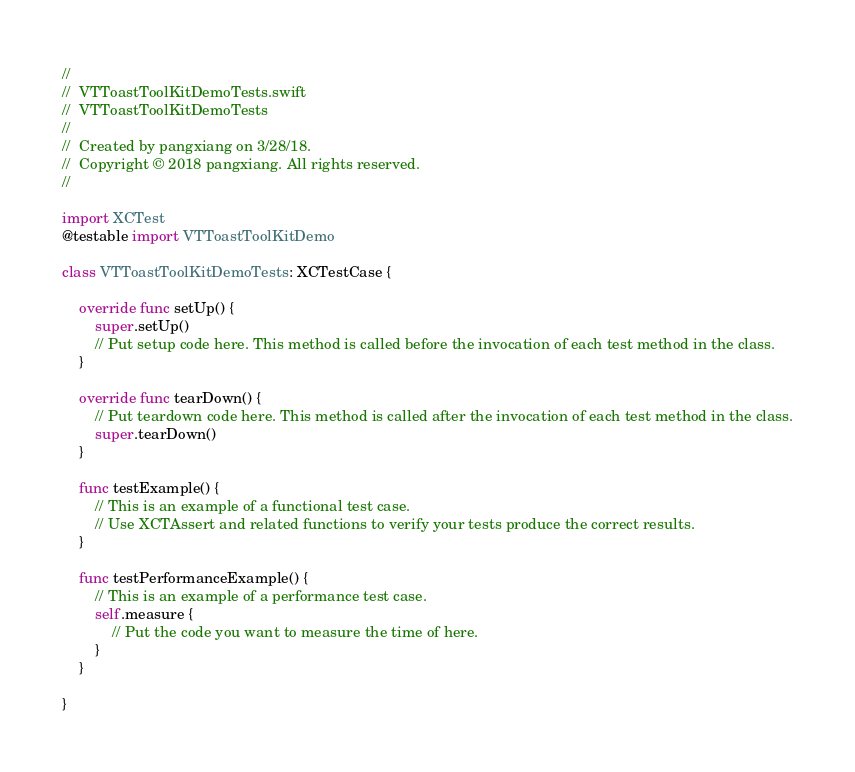Convert code to text. <code><loc_0><loc_0><loc_500><loc_500><_Swift_>//
//  VTToastToolKitDemoTests.swift
//  VTToastToolKitDemoTests
//
//  Created by pangxiang on 3/28/18.
//  Copyright © 2018 pangxiang. All rights reserved.
//

import XCTest
@testable import VTToastToolKitDemo

class VTToastToolKitDemoTests: XCTestCase {
    
    override func setUp() {
        super.setUp()
        // Put setup code here. This method is called before the invocation of each test method in the class.
    }
    
    override func tearDown() {
        // Put teardown code here. This method is called after the invocation of each test method in the class.
        super.tearDown()
    }
    
    func testExample() {
        // This is an example of a functional test case.
        // Use XCTAssert and related functions to verify your tests produce the correct results.
    }
    
    func testPerformanceExample() {
        // This is an example of a performance test case.
        self.measure {
            // Put the code you want to measure the time of here.
        }
    }
    
}
</code> 